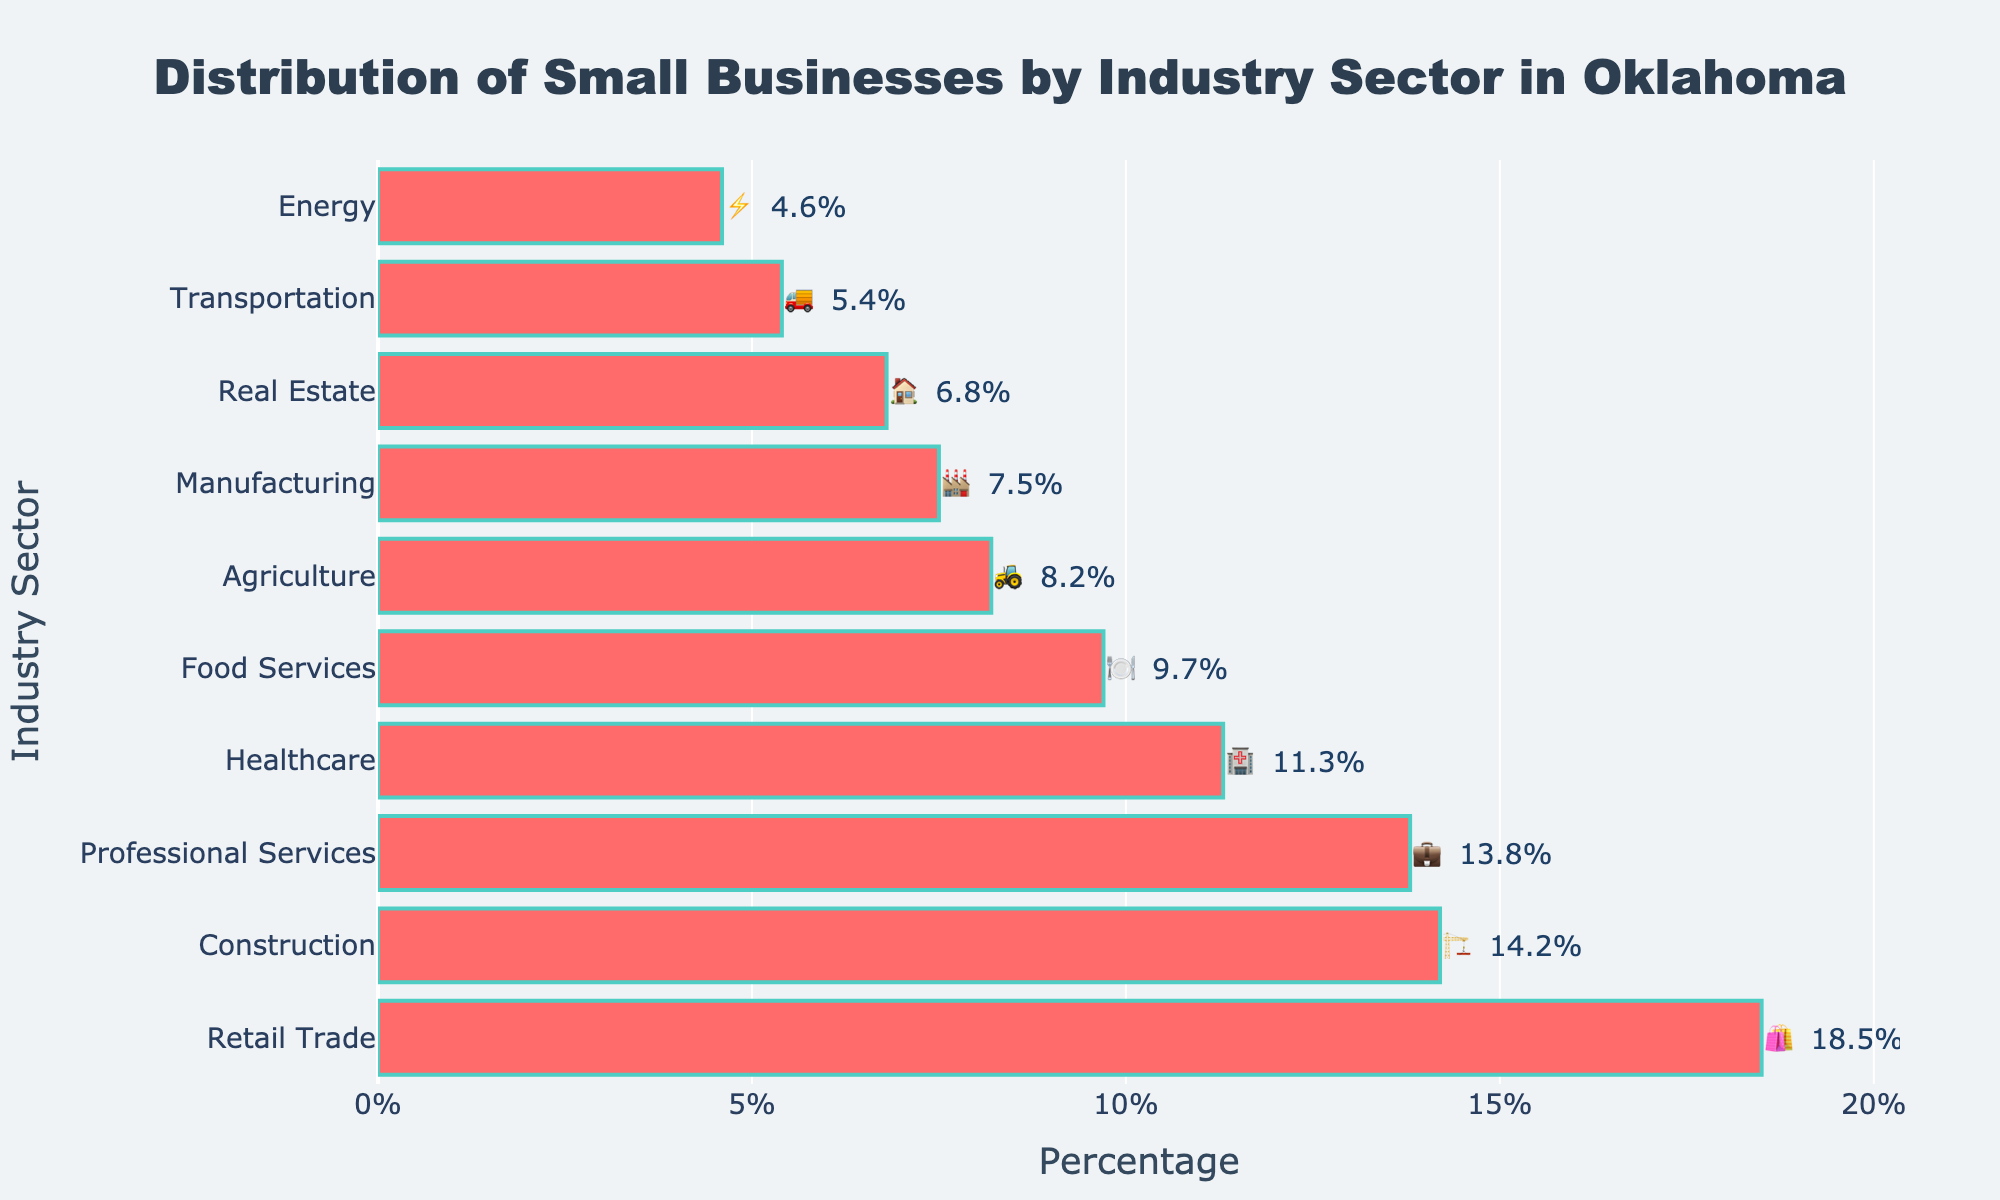What is the percentage of small businesses in the Healthcare sector? Looking at the figure, find the bar labeled 'Healthcare' accompanied by the 🏥 emoji. The text next to the bar indicates the percentage.
Answer: 11.3% What industry sector has the highest percentage of small businesses? Identify the longest bar in the figure; the industry with the corresponding emoji and label at the end represents the highest percentage of small businesses.
Answer: Retail Trade What is the combined percentage of small businesses in the Construction and Manufacturing sectors? Find the percentages for Construction (🏗️) and Manufacturing (🏭). Sum these percentages: 14.2 + 7.5.
Answer: 21.7% Which industry sectors have a higher percentage of small businesses than the Professional Services sector? The percentage for Professional Services (💼) is 13.8%. Identify bars with percentages higher than this value: Retail Trade (18.5%) and Construction (14.2%).
Answer: Retail Trade, Construction How much greater is the percentage of small businesses in Retail Trade compared to Energy? Find the percentages for Retail Trade (🛍️) and Energy (⚡). Subtract the percentage of Energy from Retail Trade: 18.5 - 4.6.
Answer: 13.9% Which industry sector comes fourth in the ranking of small businesses by percentage? Sort the bars in descending order by percentage. The fourth bar in the sequence is the one ranked fourth.
Answer: Healthcare What is the average percentage of small businesses across all sectors listed? Sum all the percentages provided in the figure and divide by the number of sectors (10): (18.5 + 14.2 + 13.8 + 11.3 + 9.7 + 8.2 + 7.5 + 6.8 + 5.4 + 4.6) / 10.
Answer: 10.0% How does the percentage of small businesses in Agriculture compare to that in Food Services? Compare the bars for Agriculture (🚜) and Food Services (🍽️). Agriculture has 8.2% and Food Services has 9.7%. Determine if one is greater and by how much.
Answer: Food Services is 1.5% greater Which sector has a smaller percentage of small businesses, Real Estate or Transportation? Compare the bars for Real Estate (🏠) and Transportation (🚚). Real Estate has 6.8% and Transportation has 5.4%. Identify the smaller one.
Answer: Transportation What is the median percentage of small businesses across the listed sectors? Order the percentages and find the middle value. For even counts, average the two central numbers [(9.7 + 8.2) / 2]. Ordered values: 18.5, 14.2, 13.8, 11.3, 9.7, 8.2, 7.5, 6.8, 5.4, 4.6. The middle two are 9.7 and 8.2.
Answer: 8.95% 